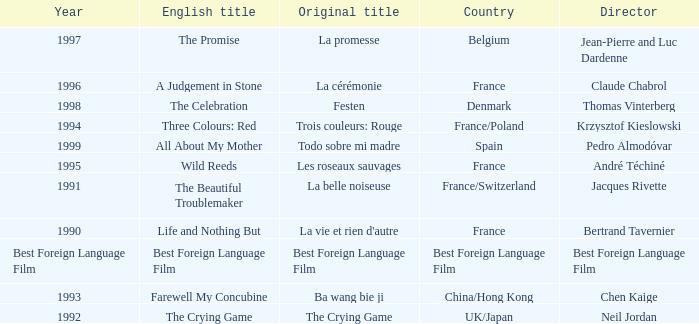What's the Original Title of the English title A Judgement in Stone? La cérémonie. 